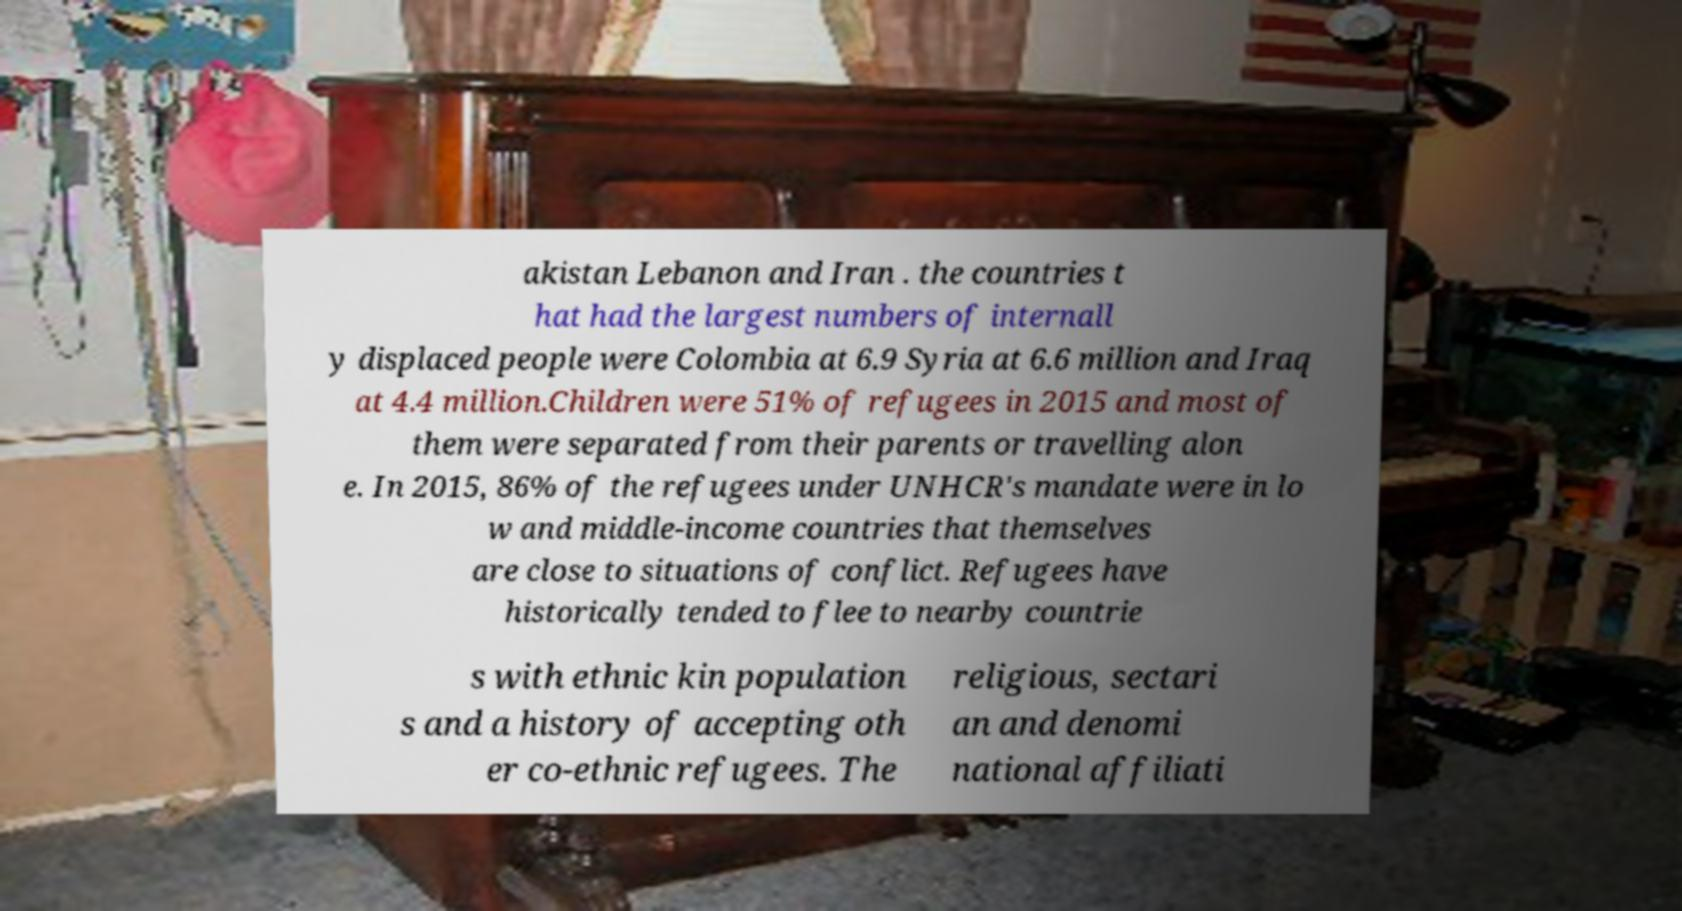I need the written content from this picture converted into text. Can you do that? akistan Lebanon and Iran . the countries t hat had the largest numbers of internall y displaced people were Colombia at 6.9 Syria at 6.6 million and Iraq at 4.4 million.Children were 51% of refugees in 2015 and most of them were separated from their parents or travelling alon e. In 2015, 86% of the refugees under UNHCR's mandate were in lo w and middle-income countries that themselves are close to situations of conflict. Refugees have historically tended to flee to nearby countrie s with ethnic kin population s and a history of accepting oth er co-ethnic refugees. The religious, sectari an and denomi national affiliati 